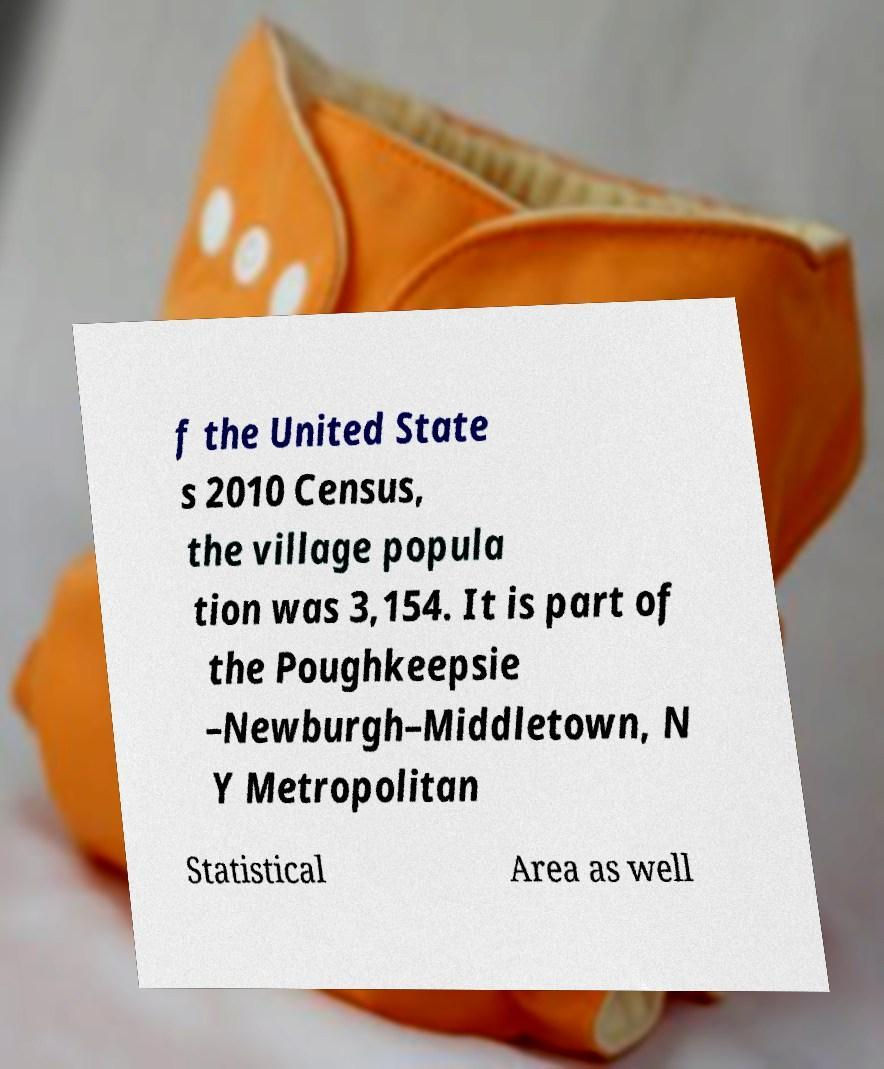Please identify and transcribe the text found in this image. f the United State s 2010 Census, the village popula tion was 3,154. It is part of the Poughkeepsie –Newburgh–Middletown, N Y Metropolitan Statistical Area as well 